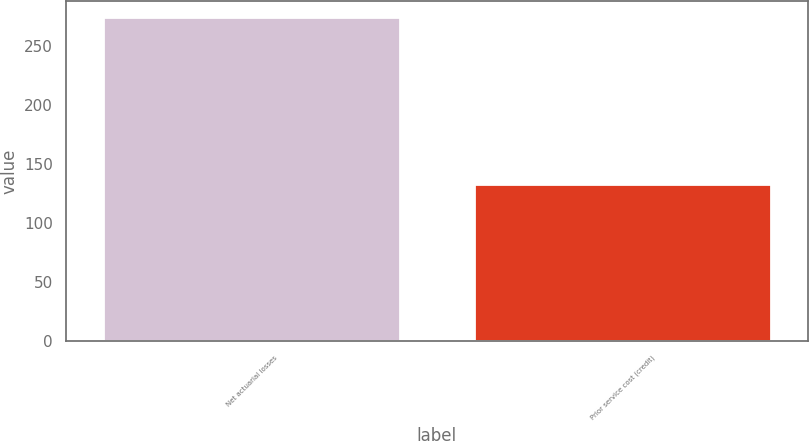Convert chart. <chart><loc_0><loc_0><loc_500><loc_500><bar_chart><fcel>Net actuarial losses<fcel>Prior service cost (credit)<nl><fcel>274<fcel>133<nl></chart> 